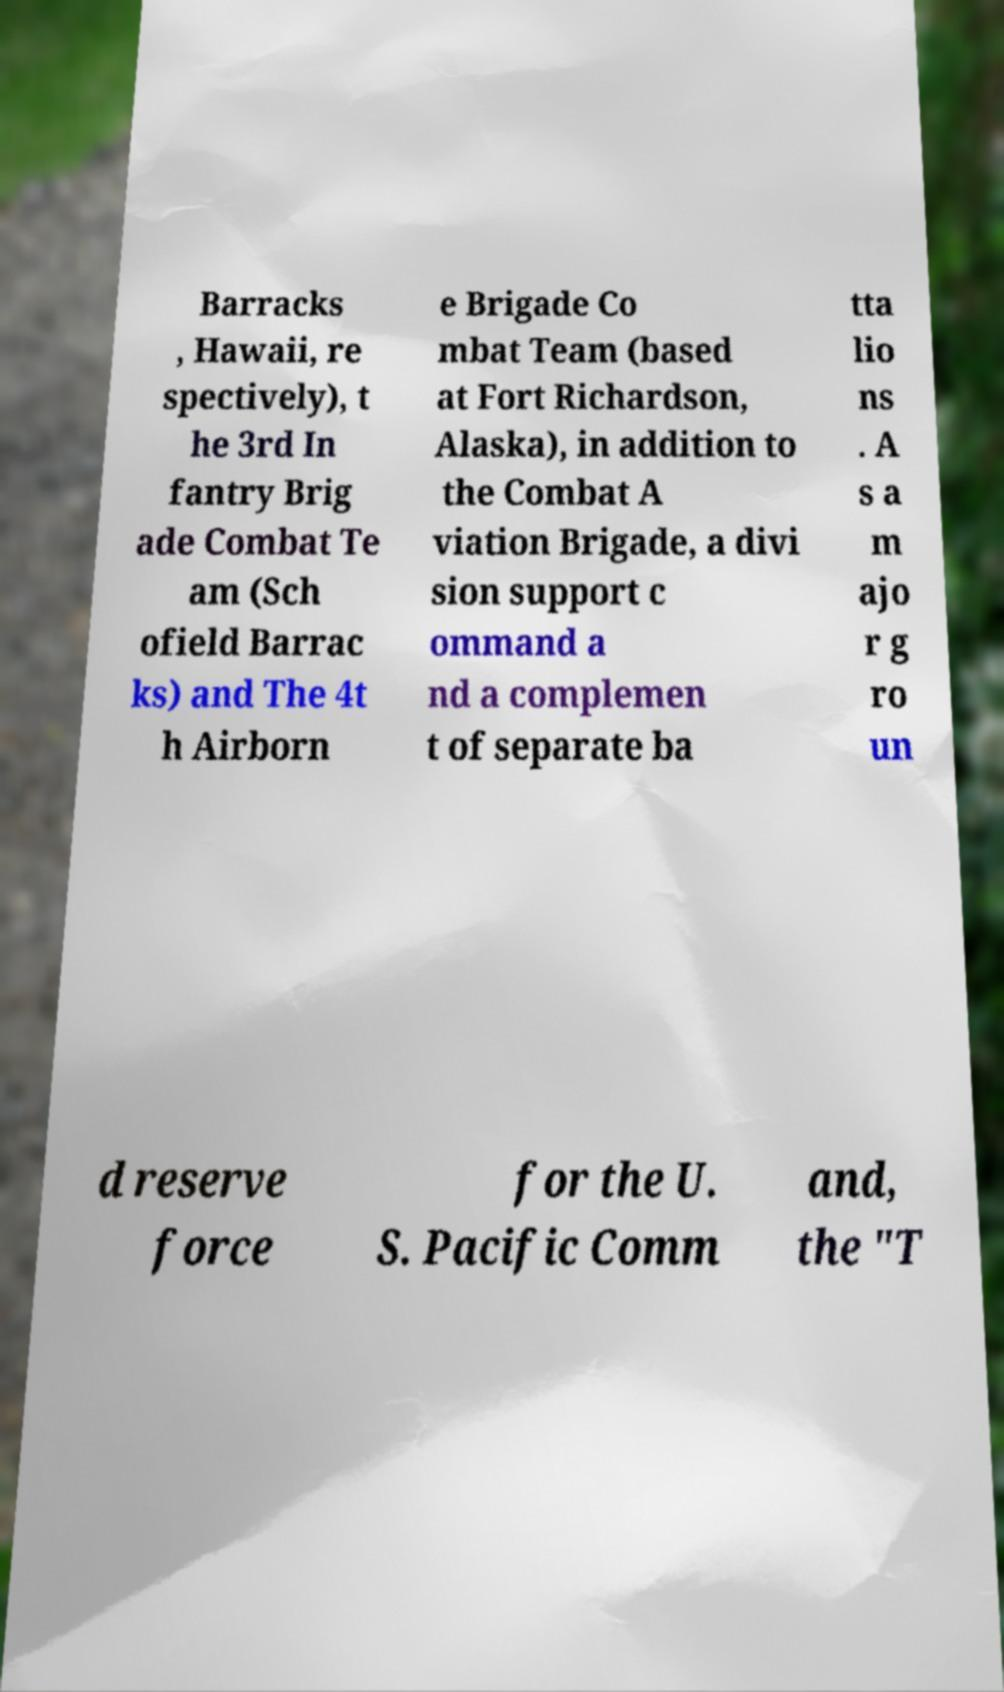What messages or text are displayed in this image? I need them in a readable, typed format. Barracks , Hawaii, re spectively), t he 3rd In fantry Brig ade Combat Te am (Sch ofield Barrac ks) and The 4t h Airborn e Brigade Co mbat Team (based at Fort Richardson, Alaska), in addition to the Combat A viation Brigade, a divi sion support c ommand a nd a complemen t of separate ba tta lio ns . A s a m ajo r g ro un d reserve force for the U. S. Pacific Comm and, the "T 